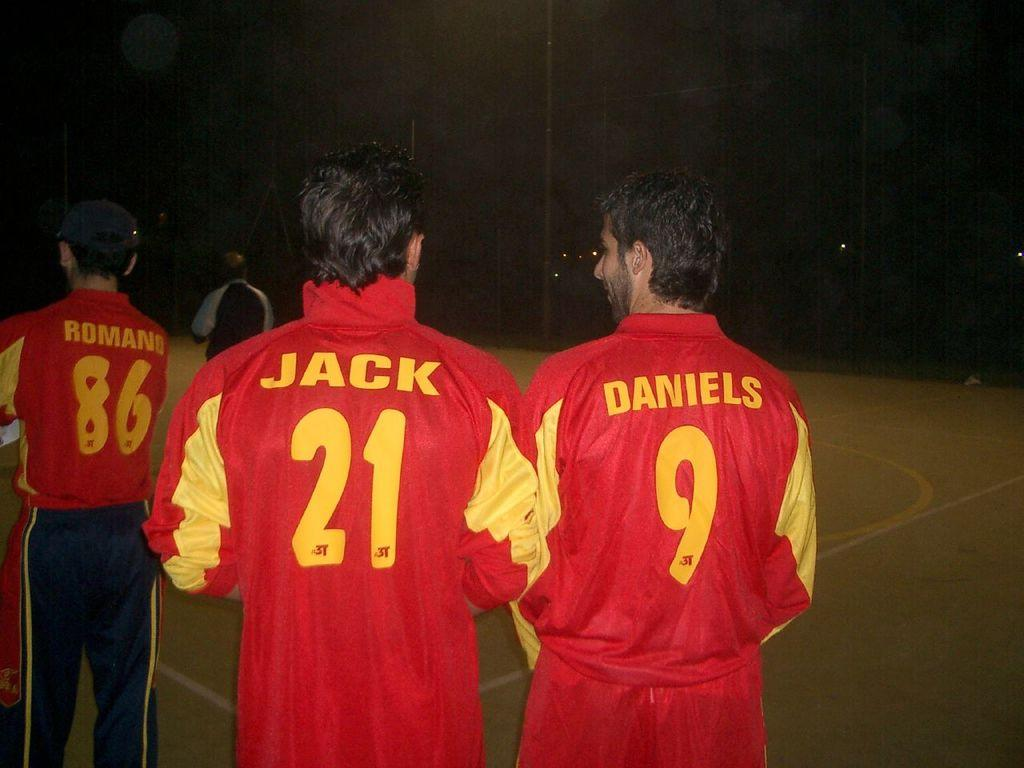<image>
Offer a succinct explanation of the picture presented. Two men are wearing matching red sport jackets that sayd "jack" on one and "daniels" on the other. 